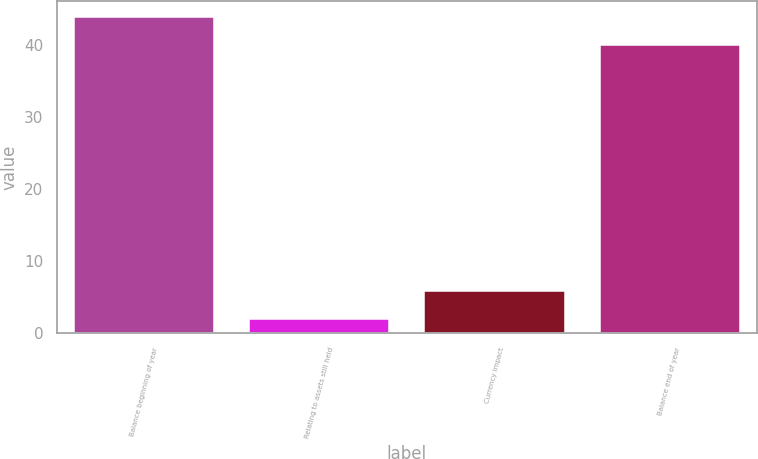Convert chart to OTSL. <chart><loc_0><loc_0><loc_500><loc_500><bar_chart><fcel>Balance beginning of year<fcel>Relating to assets still held<fcel>Currency impact<fcel>Balance end of year<nl><fcel>43.9<fcel>2<fcel>5.9<fcel>40<nl></chart> 